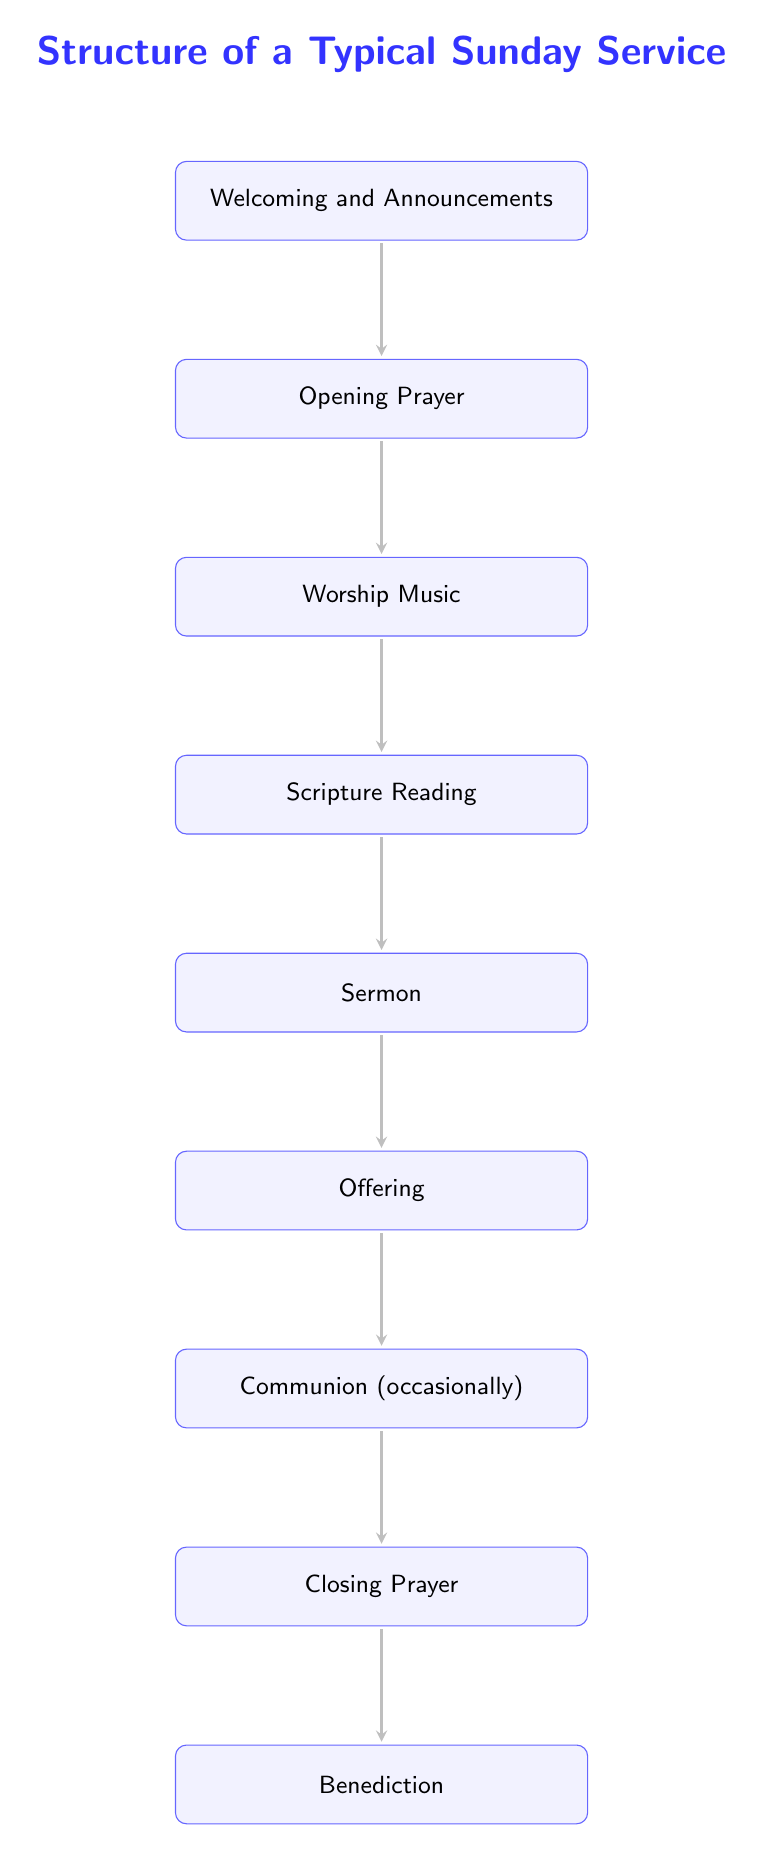What is the first component of the Sunday service? The first component listed in the diagram is "Welcoming and Announcements," which appears at the top of the sequence.
Answer: Welcoming and Announcements How many key components are there in the Sunday service structure? By counting each of the nodes listed in the diagram, there are a total of nine key components in the structure.
Answer: 9 What component follows the "Scripture Reading"? The diagram shows that "Sermon" directly follows "Scripture Reading" in the sequence of the service.
Answer: Sermon Which component might occur occasionally? The "Communion" component is noted as happening occasionally in the sequence of the service, as indicated by its placement and description in the diagram.
Answer: Communion What is the last component of the Sunday service? In examining the diagram, the last component listed in the order of the service is "Benediction."
Answer: Benediction Which two components are connected directly by an arrow after the "Offering"? The diagram demonstrates that "Offering" is directly followed by "Communion," as indicated by the arrow connecting the two components.
Answer: Communion Is there a direct link between the "Worship Music" and "Closing Prayer" components? The diagram indicates there is no direct arrow between "Worship Music" and "Closing Prayer," as they are separated by several other components in the sequence.
Answer: No What is the relationship between "Opening Prayer" and "Worship Music"? "Opening Prayer" directly connects to "Worship Music" with an arrow, indicating that "Worship Music" follows "Opening Prayer" in the service sequence.
Answer: Directly connected What sequence follows the "Offering"? From the diagram, the sequence that follows "Offering" is "Communion," and then "Closing Prayer" follows that.
Answer: Communion, Closing Prayer 